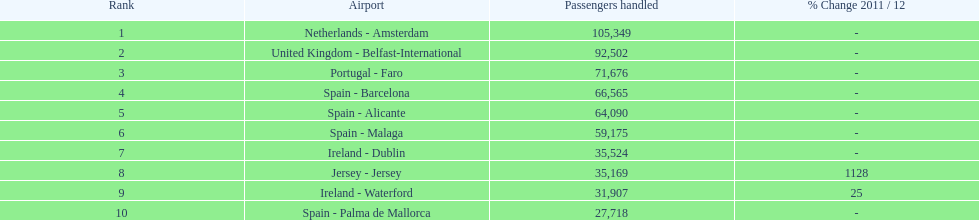Looking at the top 10 busiest routes to and from london southend airport what is the average number of passengers handled? 58,967.5. 